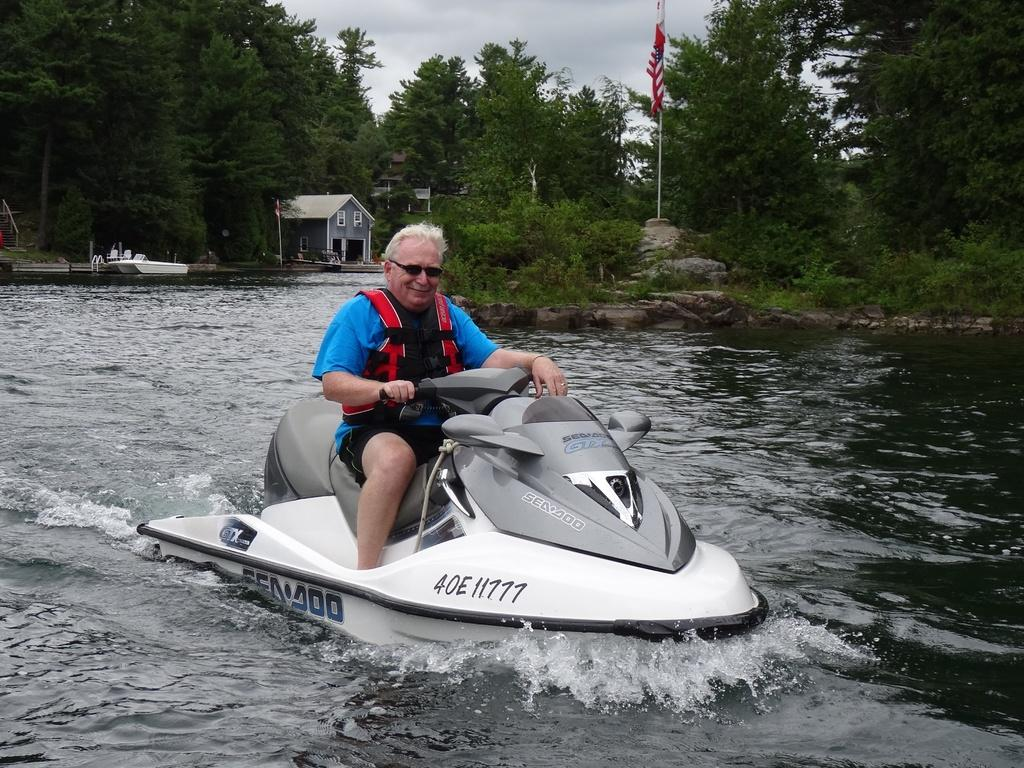<image>
Offer a succinct explanation of the picture presented. A man with grey hair is riding a jet ski that says Seadoo. 